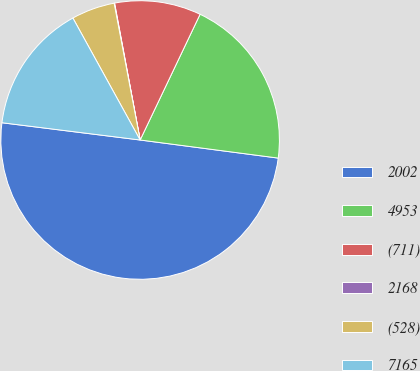Convert chart. <chart><loc_0><loc_0><loc_500><loc_500><pie_chart><fcel>2002<fcel>4953<fcel>(711)<fcel>2168<fcel>(528)<fcel>7165<nl><fcel>49.9%<fcel>19.99%<fcel>10.02%<fcel>0.05%<fcel>5.03%<fcel>15.0%<nl></chart> 